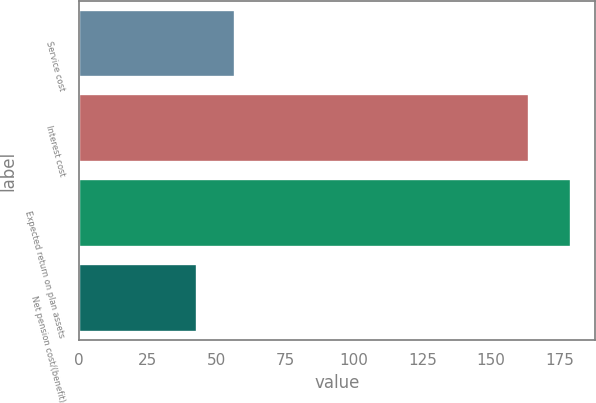<chart> <loc_0><loc_0><loc_500><loc_500><bar_chart><fcel>Service cost<fcel>Interest cost<fcel>Expected return on plan assets<fcel>Net pension cost/(benefit)<nl><fcel>56.6<fcel>164<fcel>179<fcel>43<nl></chart> 